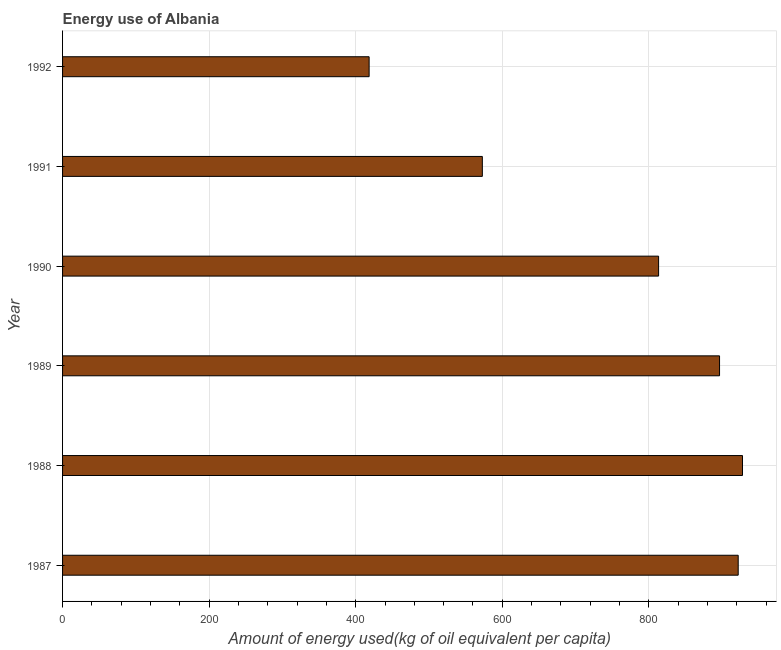Does the graph contain grids?
Make the answer very short. Yes. What is the title of the graph?
Your response must be concise. Energy use of Albania. What is the label or title of the X-axis?
Provide a succinct answer. Amount of energy used(kg of oil equivalent per capita). What is the amount of energy used in 1990?
Give a very brief answer. 813.26. Across all years, what is the maximum amount of energy used?
Your response must be concise. 927.74. Across all years, what is the minimum amount of energy used?
Your response must be concise. 418.29. What is the sum of the amount of energy used?
Your answer should be compact. 4550.4. What is the difference between the amount of energy used in 1988 and 1989?
Provide a succinct answer. 31.31. What is the average amount of energy used per year?
Provide a succinct answer. 758.4. What is the median amount of energy used?
Offer a very short reply. 854.85. Do a majority of the years between 1990 and 1987 (inclusive) have amount of energy used greater than 240 kg?
Your response must be concise. Yes. What is the ratio of the amount of energy used in 1988 to that in 1992?
Provide a short and direct response. 2.22. Is the difference between the amount of energy used in 1988 and 1992 greater than the difference between any two years?
Provide a succinct answer. Yes. What is the difference between the highest and the second highest amount of energy used?
Make the answer very short. 5.85. What is the difference between the highest and the lowest amount of energy used?
Offer a very short reply. 509.46. How many bars are there?
Your response must be concise. 6. What is the difference between two consecutive major ticks on the X-axis?
Provide a short and direct response. 200. Are the values on the major ticks of X-axis written in scientific E-notation?
Offer a terse response. No. What is the Amount of energy used(kg of oil equivalent per capita) in 1987?
Make the answer very short. 921.89. What is the Amount of energy used(kg of oil equivalent per capita) in 1988?
Keep it short and to the point. 927.74. What is the Amount of energy used(kg of oil equivalent per capita) of 1989?
Offer a terse response. 896.44. What is the Amount of energy used(kg of oil equivalent per capita) in 1990?
Provide a short and direct response. 813.26. What is the Amount of energy used(kg of oil equivalent per capita) in 1991?
Offer a very short reply. 572.78. What is the Amount of energy used(kg of oil equivalent per capita) of 1992?
Your answer should be compact. 418.29. What is the difference between the Amount of energy used(kg of oil equivalent per capita) in 1987 and 1988?
Ensure brevity in your answer.  -5.85. What is the difference between the Amount of energy used(kg of oil equivalent per capita) in 1987 and 1989?
Provide a short and direct response. 25.46. What is the difference between the Amount of energy used(kg of oil equivalent per capita) in 1987 and 1990?
Ensure brevity in your answer.  108.64. What is the difference between the Amount of energy used(kg of oil equivalent per capita) in 1987 and 1991?
Your answer should be compact. 349.11. What is the difference between the Amount of energy used(kg of oil equivalent per capita) in 1987 and 1992?
Make the answer very short. 503.61. What is the difference between the Amount of energy used(kg of oil equivalent per capita) in 1988 and 1989?
Give a very brief answer. 31.31. What is the difference between the Amount of energy used(kg of oil equivalent per capita) in 1988 and 1990?
Offer a terse response. 114.49. What is the difference between the Amount of energy used(kg of oil equivalent per capita) in 1988 and 1991?
Offer a terse response. 354.96. What is the difference between the Amount of energy used(kg of oil equivalent per capita) in 1988 and 1992?
Ensure brevity in your answer.  509.46. What is the difference between the Amount of energy used(kg of oil equivalent per capita) in 1989 and 1990?
Make the answer very short. 83.18. What is the difference between the Amount of energy used(kg of oil equivalent per capita) in 1989 and 1991?
Give a very brief answer. 323.66. What is the difference between the Amount of energy used(kg of oil equivalent per capita) in 1989 and 1992?
Your answer should be compact. 478.15. What is the difference between the Amount of energy used(kg of oil equivalent per capita) in 1990 and 1991?
Your answer should be very brief. 240.47. What is the difference between the Amount of energy used(kg of oil equivalent per capita) in 1990 and 1992?
Your answer should be compact. 394.97. What is the difference between the Amount of energy used(kg of oil equivalent per capita) in 1991 and 1992?
Your response must be concise. 154.5. What is the ratio of the Amount of energy used(kg of oil equivalent per capita) in 1987 to that in 1988?
Your answer should be very brief. 0.99. What is the ratio of the Amount of energy used(kg of oil equivalent per capita) in 1987 to that in 1989?
Your answer should be compact. 1.03. What is the ratio of the Amount of energy used(kg of oil equivalent per capita) in 1987 to that in 1990?
Your answer should be very brief. 1.13. What is the ratio of the Amount of energy used(kg of oil equivalent per capita) in 1987 to that in 1991?
Make the answer very short. 1.61. What is the ratio of the Amount of energy used(kg of oil equivalent per capita) in 1987 to that in 1992?
Your answer should be compact. 2.2. What is the ratio of the Amount of energy used(kg of oil equivalent per capita) in 1988 to that in 1989?
Keep it short and to the point. 1.03. What is the ratio of the Amount of energy used(kg of oil equivalent per capita) in 1988 to that in 1990?
Your response must be concise. 1.14. What is the ratio of the Amount of energy used(kg of oil equivalent per capita) in 1988 to that in 1991?
Make the answer very short. 1.62. What is the ratio of the Amount of energy used(kg of oil equivalent per capita) in 1988 to that in 1992?
Provide a succinct answer. 2.22. What is the ratio of the Amount of energy used(kg of oil equivalent per capita) in 1989 to that in 1990?
Provide a succinct answer. 1.1. What is the ratio of the Amount of energy used(kg of oil equivalent per capita) in 1989 to that in 1991?
Make the answer very short. 1.56. What is the ratio of the Amount of energy used(kg of oil equivalent per capita) in 1989 to that in 1992?
Offer a very short reply. 2.14. What is the ratio of the Amount of energy used(kg of oil equivalent per capita) in 1990 to that in 1991?
Your answer should be very brief. 1.42. What is the ratio of the Amount of energy used(kg of oil equivalent per capita) in 1990 to that in 1992?
Give a very brief answer. 1.94. What is the ratio of the Amount of energy used(kg of oil equivalent per capita) in 1991 to that in 1992?
Your answer should be very brief. 1.37. 